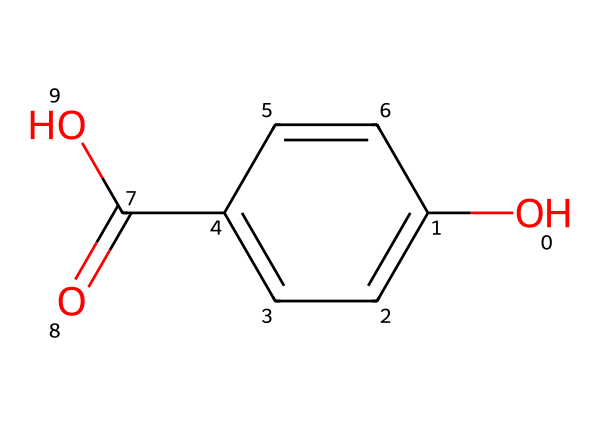What is the main functional group present in this compound? The visible -OH group indicates the presence of a hydroxyl group, which is characteristic of phenolic compounds. This group is responsible for phenolic behavior.
Answer: hydroxyl How many carbon atoms are in this chemical structure? By analyzing the SMILES representation, there are six carbon atoms in the phenolic ring and one carbon in the carboxylic acid group, totaling seven carbon atoms.
Answer: seven What type of acid is represented by the carboxylic group in this compound? The presence of the -COOH group (carboxylic acid) shows that this compound is a carboxylic acid, specifically benzoic acid due to its phenolic structure.
Answer: benzoic acid Is this compound likely to exhibit antioxidant properties? Phenolic compounds generally exhibit antioxidant properties due to their ability to donate hydrogen and neutralize free radicals, as indicated by the -OH group in the structure.
Answer: yes Which type of reaction is primarily associated with the hydroxy groups in phenolic compounds? Hydroxy groups participate in oxidation reactions, leading to various transformations and interactions with other molecules, typical of phenolic behavior.
Answer: oxidation What is the molecular formula of the compound based on its structure? From the SMILES representation, the molecular formula can be derived as C7H6O3, accounting for the six carbon atoms from the ring, one from the carboxylic group, and three oxygens.
Answer: C7H6O3 